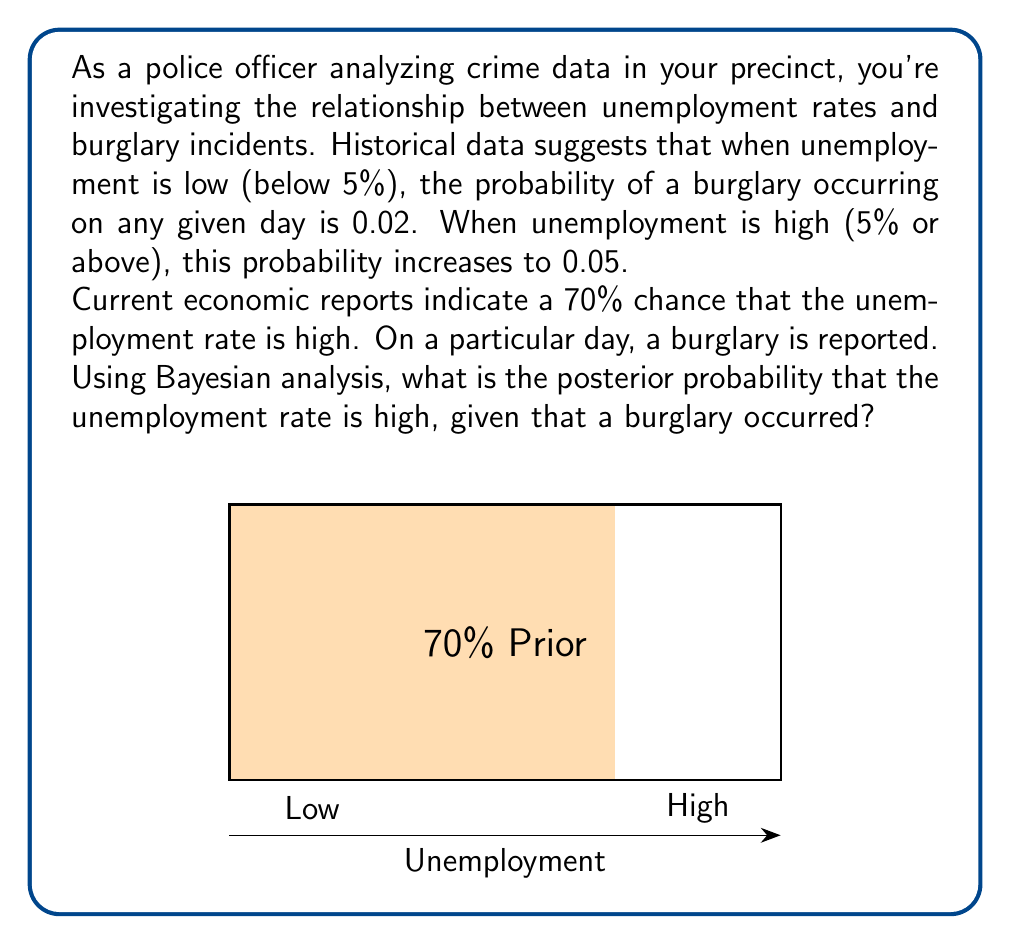Give your solution to this math problem. Let's approach this step-by-step using Bayes' theorem:

1) Define our events:
   H: Unemployment is high
   B: Burglary occurs

2) Given information:
   P(H) = 0.70 (prior probability of high unemployment)
   P(B|H) = 0.05 (probability of burglary given high unemployment)
   P(B|not H) = 0.02 (probability of burglary given low unemployment)

3) We want to find P(H|B) using Bayes' theorem:

   $$P(H|B) = \frac{P(B|H) \cdot P(H)}{P(B)}$$

4) We need to calculate P(B) using the law of total probability:

   $$P(B) = P(B|H) \cdot P(H) + P(B|\text{not }H) \cdot P(\text{not }H)$$
   $$P(B) = 0.05 \cdot 0.70 + 0.02 \cdot 0.30$$
   $$P(B) = 0.035 + 0.006 = 0.041$$

5) Now we can apply Bayes' theorem:

   $$P(H|B) = \frac{0.05 \cdot 0.70}{0.041} \approx 0.8537$$

6) Convert to a percentage:
   0.8537 * 100 ≈ 85.37%

Therefore, given that a burglary occurred, there is approximately an 85.37% chance that the unemployment rate is high.
Answer: 85.37% 